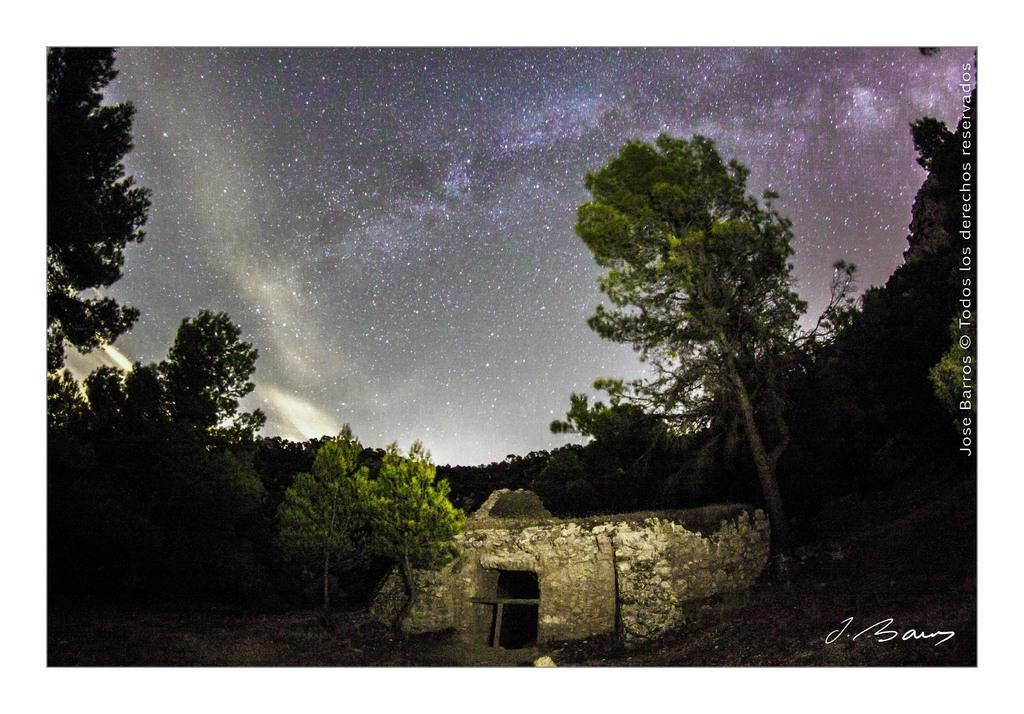What can be observed about the image's appearance? The image appears to be edited. What type of structure is present in the image? There is a wall in the image. What type of vegetation is visible in the image? There are trees in the image. What part of the natural environment is visible in the image? The sky is visible in the image. What additional feature can be seen on the image? The image contains watermarks. What type of marble is used to construct the wall in the image? There is no marble mentioned or visible in the image; it only states that there is a wall present. Can you see any corn growing in the image? There is no corn visible in the image; it only mentions trees and a wall. 